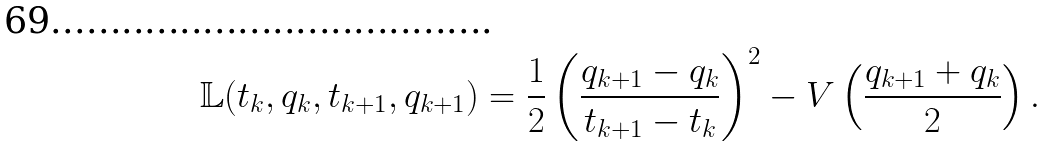Convert formula to latex. <formula><loc_0><loc_0><loc_500><loc_500>\mathbb { L } ( t _ { k } , q _ { k } , t _ { k + 1 } , q _ { k + 1 } ) = \frac { 1 } { 2 } \left ( \frac { q _ { k + 1 } - q _ { k } } { t _ { k + 1 } - t _ { k } } \right ) ^ { 2 } - V \left ( \frac { q _ { k + 1 } + q _ { k } } { 2 } \right ) .</formula> 